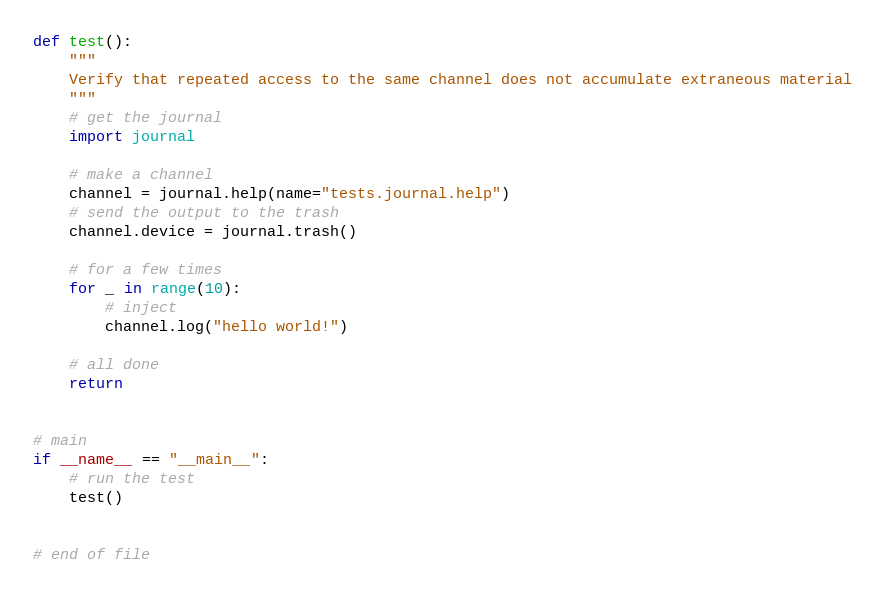Convert code to text. <code><loc_0><loc_0><loc_500><loc_500><_Python_>

def test():
    """
    Verify that repeated access to the same channel does not accumulate extraneous material
    """
    # get the journal
    import journal

    # make a channel
    channel = journal.help(name="tests.journal.help")
    # send the output to the trash
    channel.device = journal.trash()

    # for a few times
    for _ in range(10):
        # inject
        channel.log("hello world!")

    # all done
    return


# main
if __name__ == "__main__":
    # run the test
    test()


# end of file
</code> 